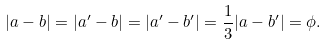Convert formula to latex. <formula><loc_0><loc_0><loc_500><loc_500>| a - b | = | a ^ { \prime } - b | = | a ^ { \prime } - b ^ { \prime } | = \frac { 1 } { 3 } | a - b ^ { \prime } | = \phi .</formula> 